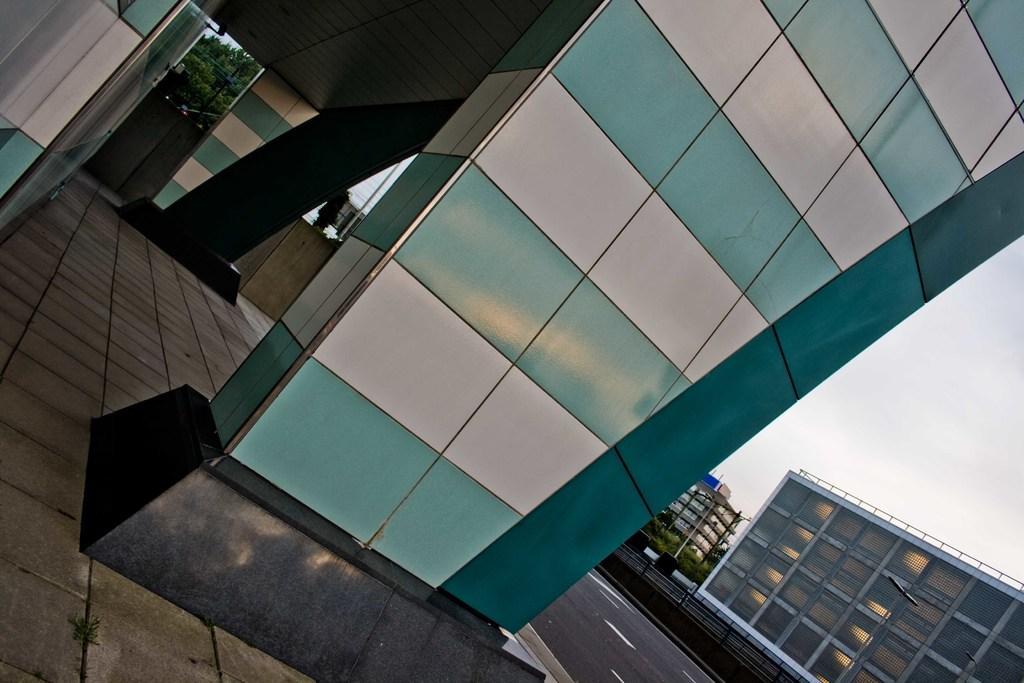Could you give a brief overview of what you see in this image? In this image I can see the glass building. In the background I can see few trees in green color. I can also see few buildings and the sky is in white color. 